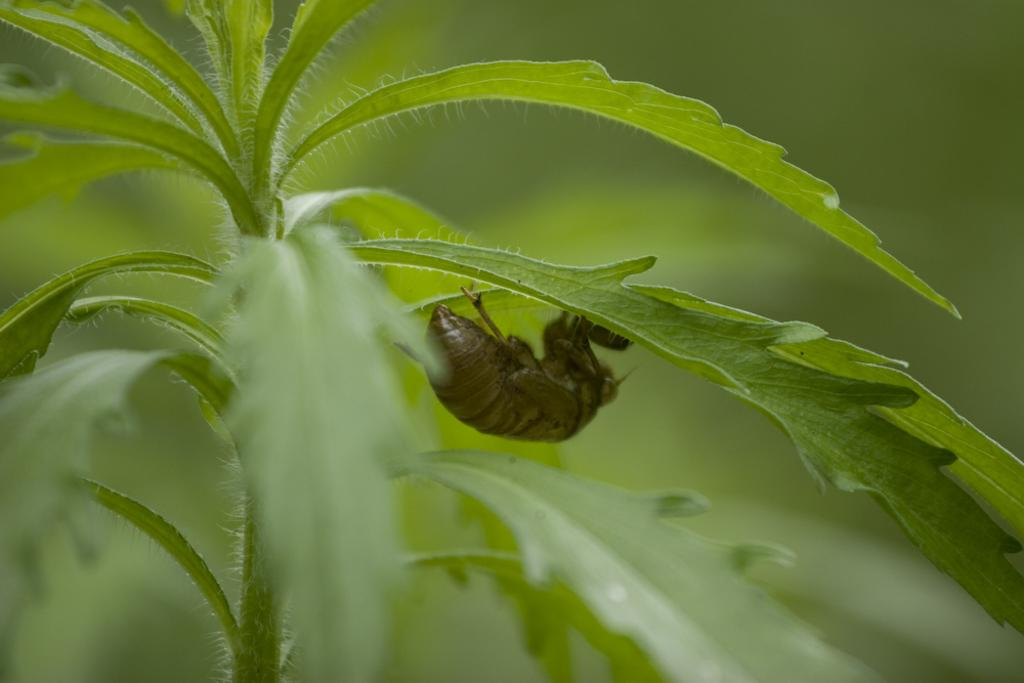What is the main subject in the center of the image? There is an insect in the center of the image. What can be seen in the background of the image? There are plants in the background of the image. What type of discussion is taking place between the insect and the tiger in the image? There is no tiger present in the image, so there cannot be a discussion between the insect and a tiger. 